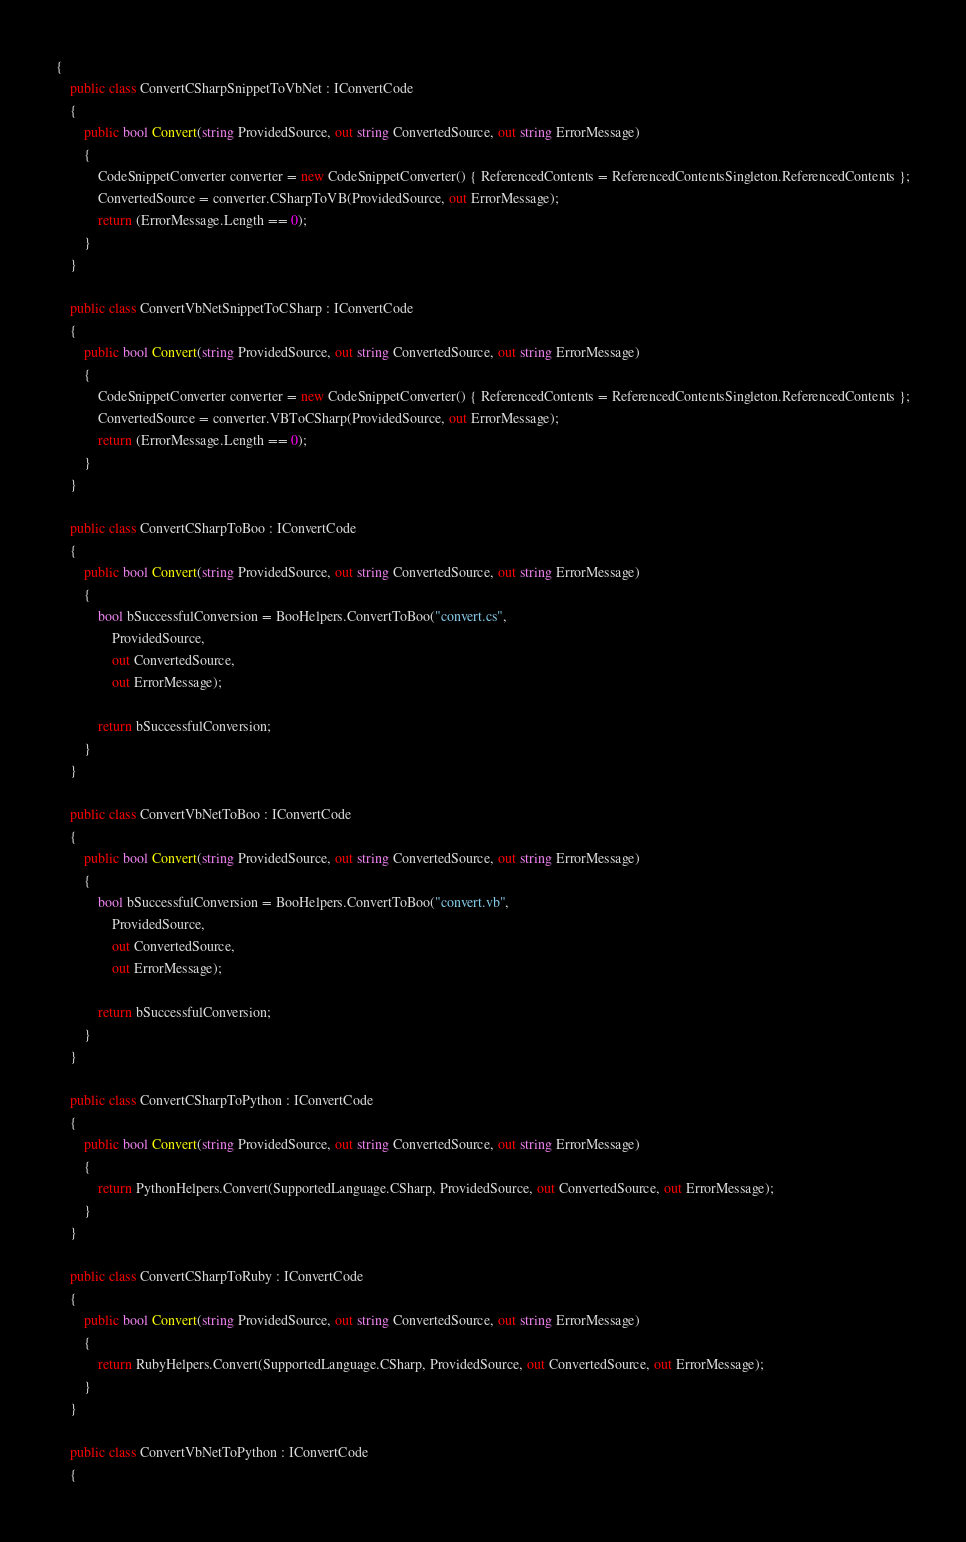Convert code to text. <code><loc_0><loc_0><loc_500><loc_500><_C#_>{
    public class ConvertCSharpSnippetToVbNet : IConvertCode
    {
        public bool Convert(string ProvidedSource, out string ConvertedSource, out string ErrorMessage)
        {
            CodeSnippetConverter converter = new CodeSnippetConverter() { ReferencedContents = ReferencedContentsSingleton.ReferencedContents };
            ConvertedSource = converter.CSharpToVB(ProvidedSource, out ErrorMessage);
            return (ErrorMessage.Length == 0);
        }
    }

    public class ConvertVbNetSnippetToCSharp : IConvertCode
    {
        public bool Convert(string ProvidedSource, out string ConvertedSource, out string ErrorMessage)
        {
            CodeSnippetConverter converter = new CodeSnippetConverter() { ReferencedContents = ReferencedContentsSingleton.ReferencedContents };
            ConvertedSource = converter.VBToCSharp(ProvidedSource, out ErrorMessage);
            return (ErrorMessage.Length == 0);
        }
    }

    public class ConvertCSharpToBoo : IConvertCode
    {
        public bool Convert(string ProvidedSource, out string ConvertedSource, out string ErrorMessage)
        {
            bool bSuccessfulConversion = BooHelpers.ConvertToBoo("convert.cs",
                ProvidedSource,
                out ConvertedSource,
                out ErrorMessage);

            return bSuccessfulConversion;
        }
    }

    public class ConvertVbNetToBoo : IConvertCode
    {
        public bool Convert(string ProvidedSource, out string ConvertedSource, out string ErrorMessage)
        {
            bool bSuccessfulConversion = BooHelpers.ConvertToBoo("convert.vb",
                ProvidedSource,
                out ConvertedSource,
                out ErrorMessage);

            return bSuccessfulConversion;
        }
    }

    public class ConvertCSharpToPython : IConvertCode
    {
        public bool Convert(string ProvidedSource, out string ConvertedSource, out string ErrorMessage)
        {
            return PythonHelpers.Convert(SupportedLanguage.CSharp, ProvidedSource, out ConvertedSource, out ErrorMessage);
        }
    }

    public class ConvertCSharpToRuby : IConvertCode
    {
        public bool Convert(string ProvidedSource, out string ConvertedSource, out string ErrorMessage)
        {
            return RubyHelpers.Convert(SupportedLanguage.CSharp, ProvidedSource, out ConvertedSource, out ErrorMessage);
        }
    }

    public class ConvertVbNetToPython : IConvertCode
    {</code> 